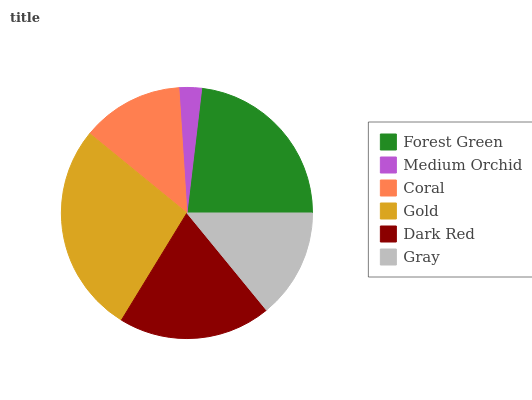Is Medium Orchid the minimum?
Answer yes or no. Yes. Is Gold the maximum?
Answer yes or no. Yes. Is Coral the minimum?
Answer yes or no. No. Is Coral the maximum?
Answer yes or no. No. Is Coral greater than Medium Orchid?
Answer yes or no. Yes. Is Medium Orchid less than Coral?
Answer yes or no. Yes. Is Medium Orchid greater than Coral?
Answer yes or no. No. Is Coral less than Medium Orchid?
Answer yes or no. No. Is Dark Red the high median?
Answer yes or no. Yes. Is Gray the low median?
Answer yes or no. Yes. Is Coral the high median?
Answer yes or no. No. Is Dark Red the low median?
Answer yes or no. No. 